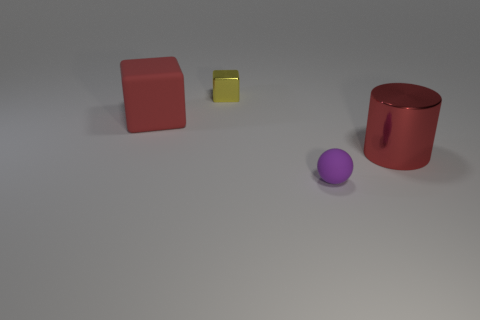Add 1 matte blocks. How many objects exist? 5 Subtract all balls. How many objects are left? 3 Subtract 0 cyan spheres. How many objects are left? 4 Subtract all large red rubber objects. Subtract all small gray shiny balls. How many objects are left? 3 Add 2 purple matte spheres. How many purple matte spheres are left? 3 Add 3 cyan matte blocks. How many cyan matte blocks exist? 3 